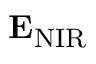<formula> <loc_0><loc_0><loc_500><loc_500>{ E } _ { N I R }</formula> 